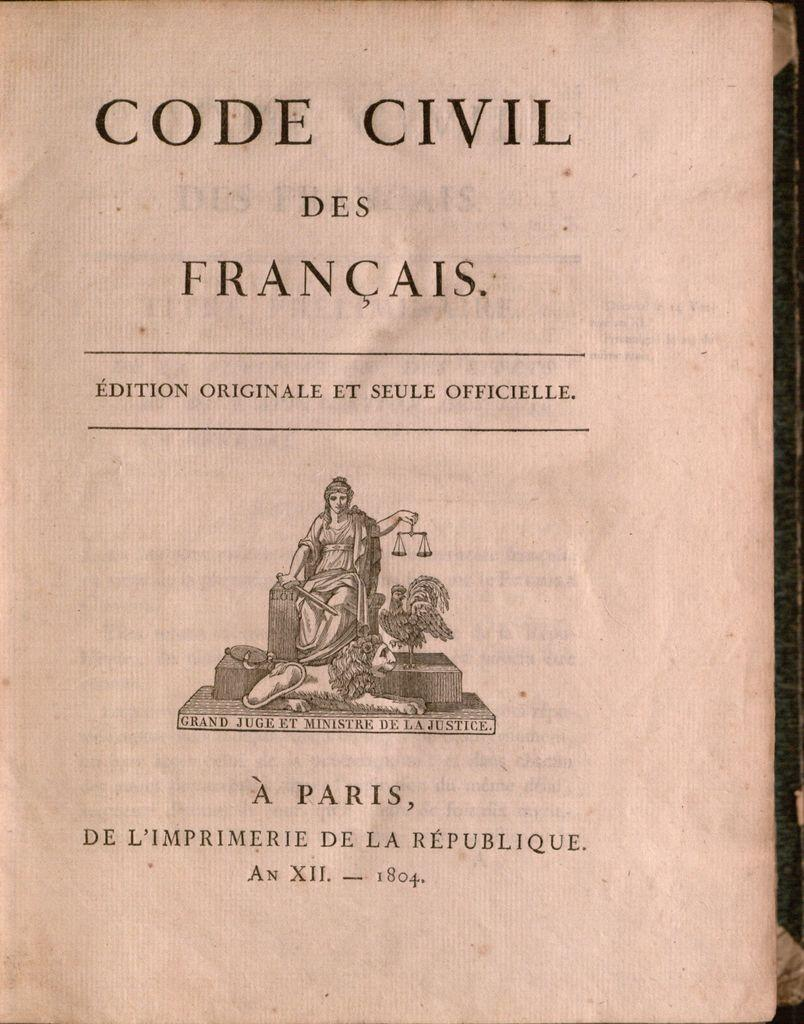<image>
Relay a brief, clear account of the picture shown. A book  titled Code Civil Des Francais has a picture women holding a balance scale on the cover. 